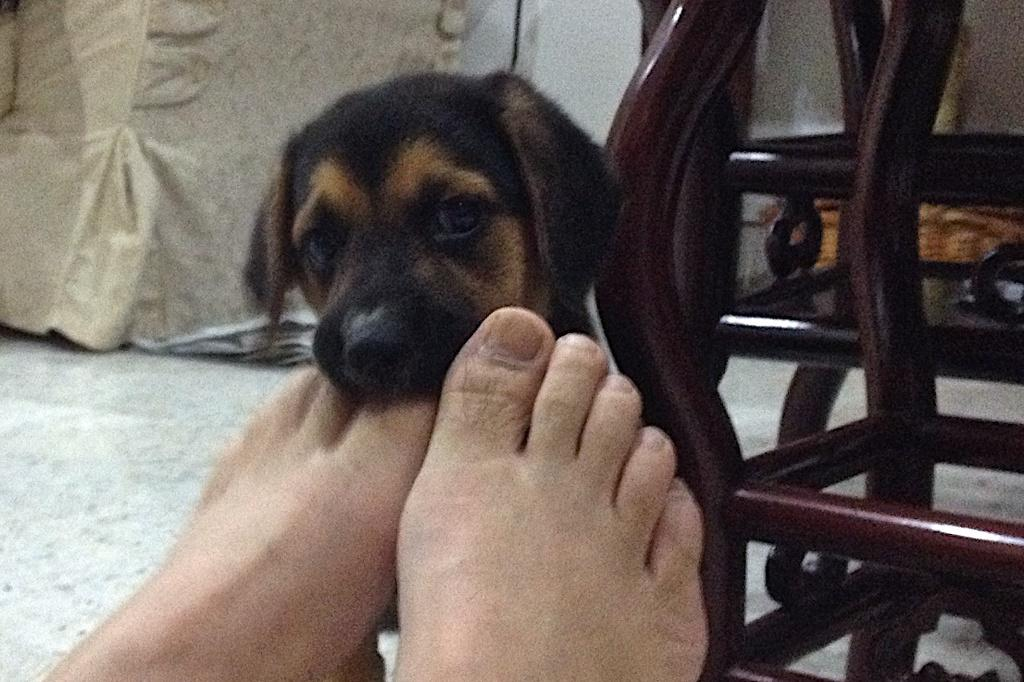What part of a person can be seen in the image? There are two legs of a person in the image. What type of animal is present in the image? There is a black and brown color dog in the image. What surface is visible in the image? There is a floor in the image. What type of nose can be seen on the dog in the image? There is no nose visible in the image; only the black and brown color of the dog can be seen. 